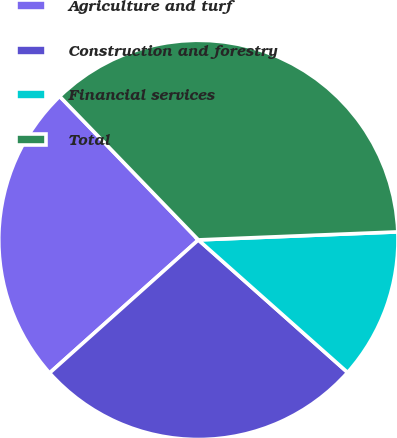Convert chart. <chart><loc_0><loc_0><loc_500><loc_500><pie_chart><fcel>Agriculture and turf<fcel>Construction and forestry<fcel>Financial services<fcel>Total<nl><fcel>24.39%<fcel>26.83%<fcel>12.2%<fcel>36.59%<nl></chart> 